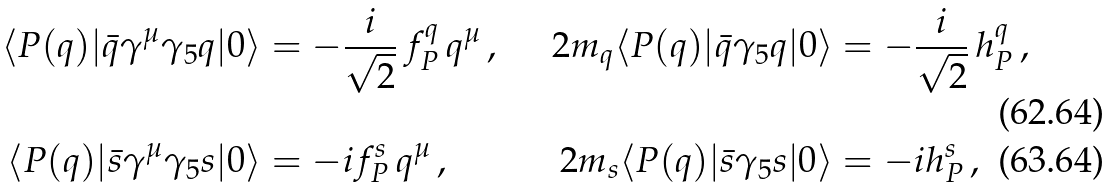Convert formula to latex. <formula><loc_0><loc_0><loc_500><loc_500>\langle P ( q ) | \bar { q } \gamma ^ { \mu } \gamma _ { 5 } q | 0 \rangle & = - \frac { i } { \sqrt { 2 } } \, f _ { P } ^ { q } \, q ^ { \mu } \, , \quad & 2 m _ { q } \langle P ( q ) | \bar { q } \gamma _ { 5 } q | 0 \rangle & = - \frac { i } { \sqrt { 2 } } \, h _ { P } ^ { q } \, , \\ \langle P ( q ) | \bar { s } \gamma ^ { \mu } \gamma _ { 5 } s | 0 \rangle & = - i f _ { P } ^ { s } \, q ^ { \mu } \, , & 2 m _ { s } \langle P ( q ) | \bar { s } \gamma _ { 5 } s | 0 \rangle & = - i h _ { P } ^ { s } \, ,</formula> 